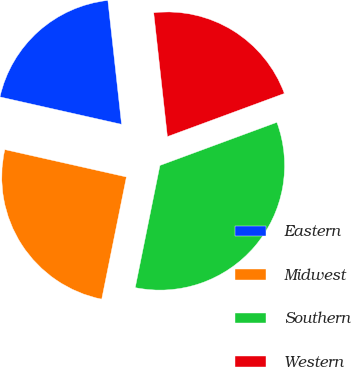Convert chart. <chart><loc_0><loc_0><loc_500><loc_500><pie_chart><fcel>Eastern<fcel>Midwest<fcel>Southern<fcel>Western<nl><fcel>19.72%<fcel>25.35%<fcel>33.8%<fcel>21.13%<nl></chart> 